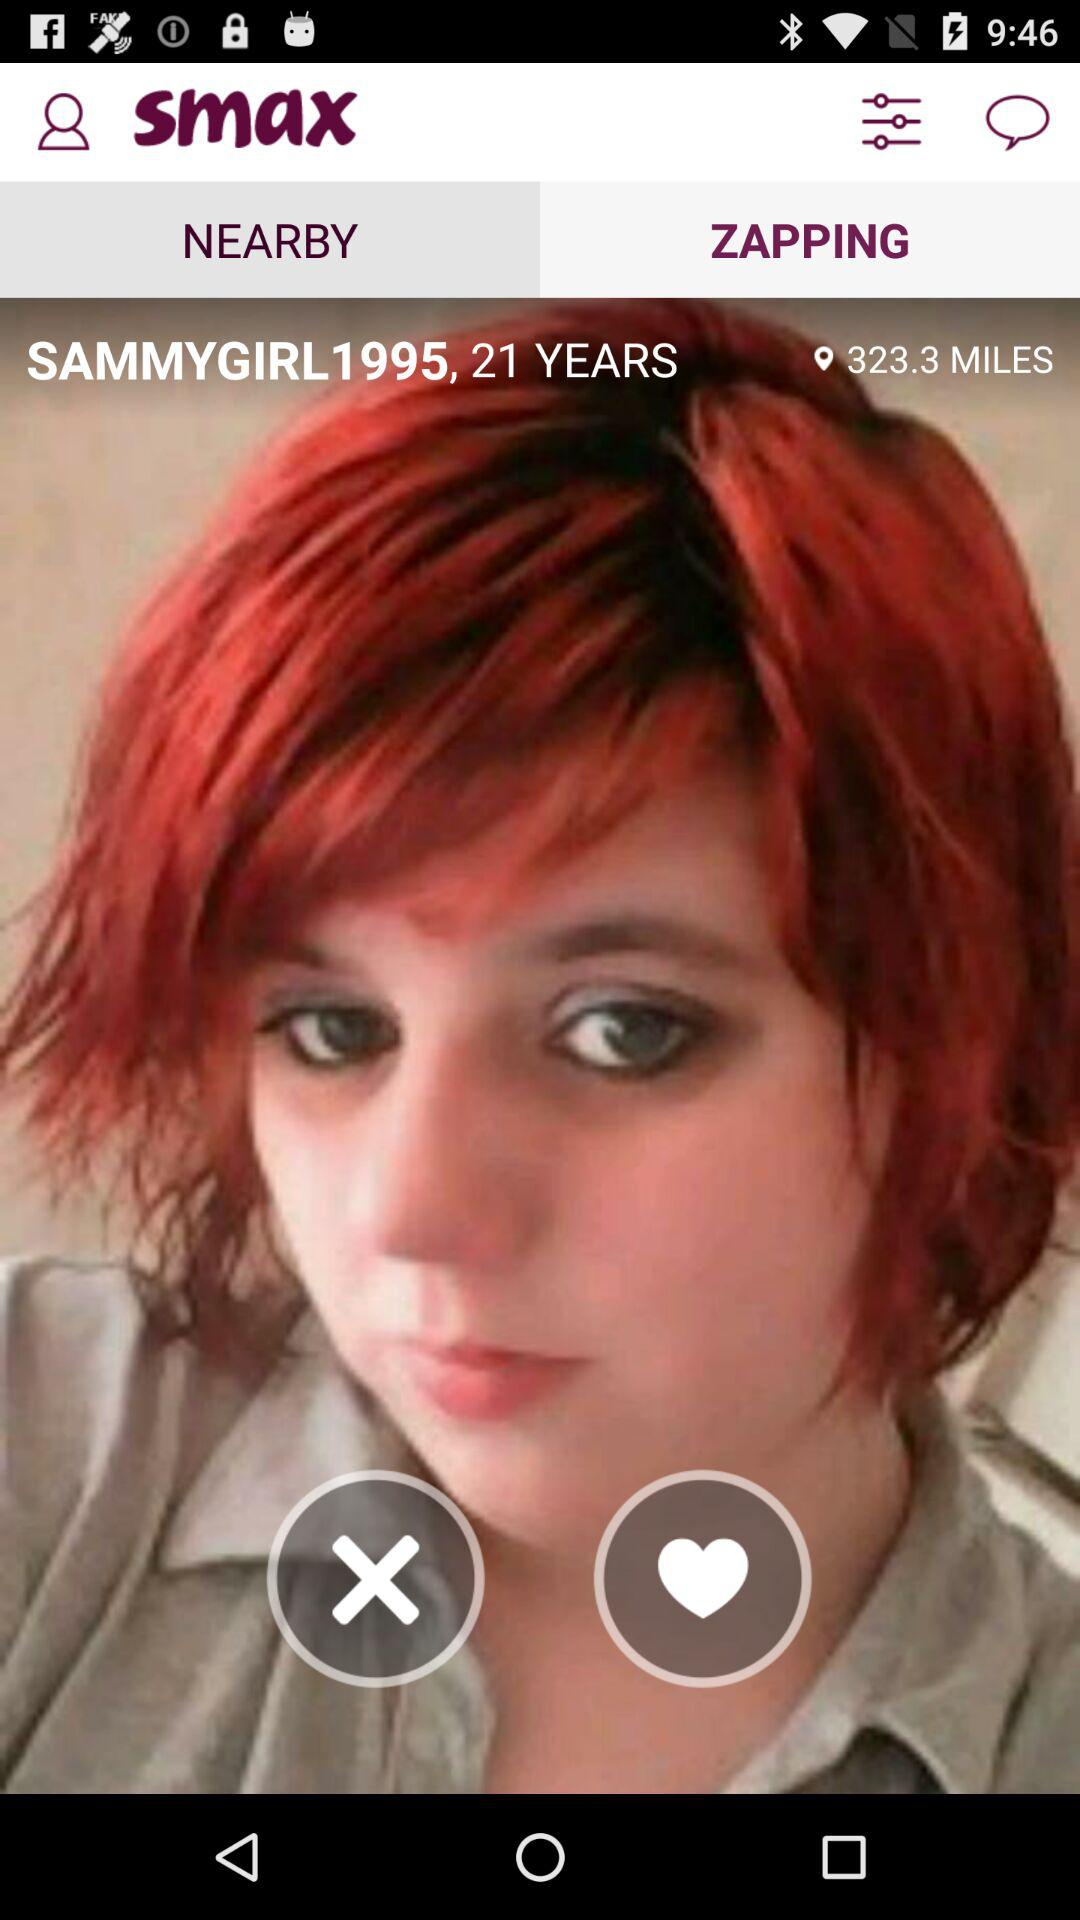How many years old is the person?
Answer the question using a single word or phrase. 21 